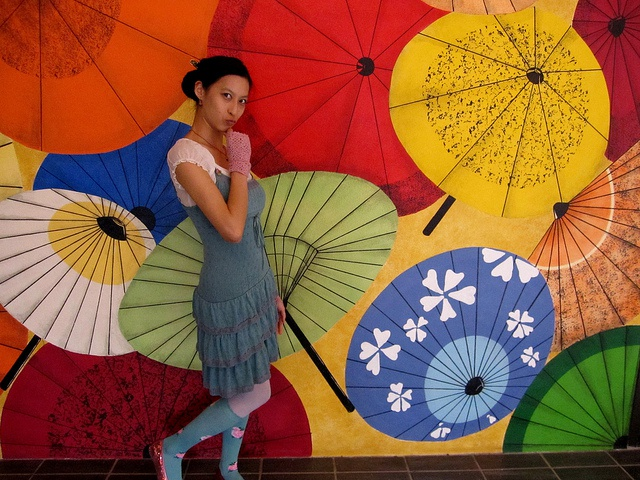Describe the objects in this image and their specific colors. I can see umbrella in maroon, orange, olive, and gold tones, umbrella in maroon, brown, and black tones, umbrella in maroon, blue, lightgray, and darkgray tones, people in maroon, gray, blue, black, and brown tones, and umbrella in maroon, brown, and red tones in this image. 